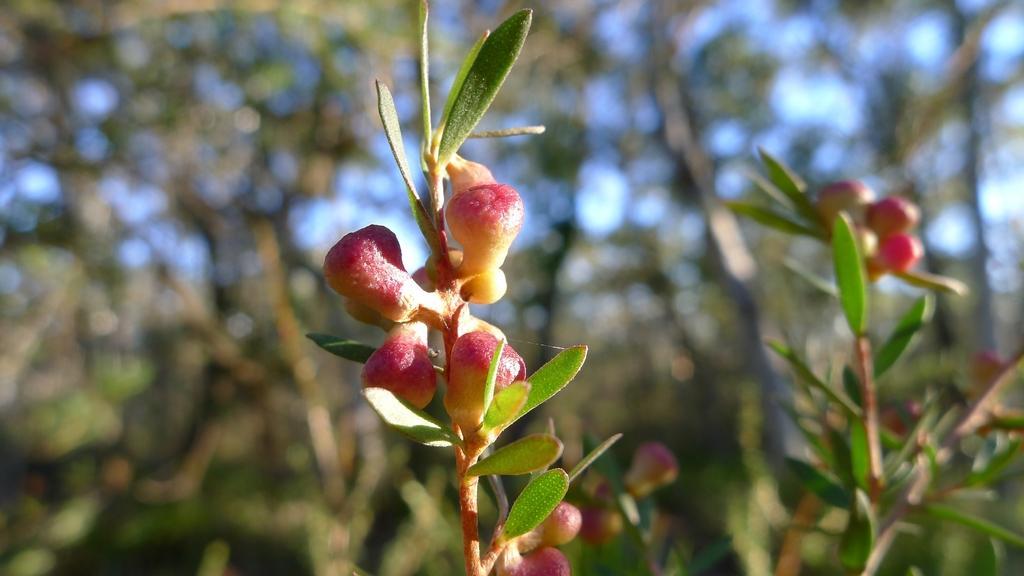Can you describe this image briefly? In this image we can see buds to the plants. In the background there are trees and sky. 